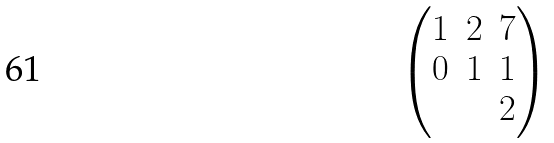Convert formula to latex. <formula><loc_0><loc_0><loc_500><loc_500>\begin{pmatrix} 1 & 2 & 7 \\ 0 & 1 & 1 \\ & & 2 \end{pmatrix}</formula> 